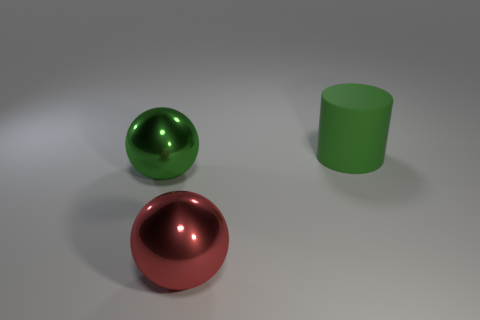Add 3 tiny red metallic balls. How many objects exist? 6 Subtract all spheres. How many objects are left? 1 Add 3 large objects. How many large objects are left? 6 Add 2 metallic balls. How many metallic balls exist? 4 Subtract 1 red balls. How many objects are left? 2 Subtract all large cubes. Subtract all big green balls. How many objects are left? 2 